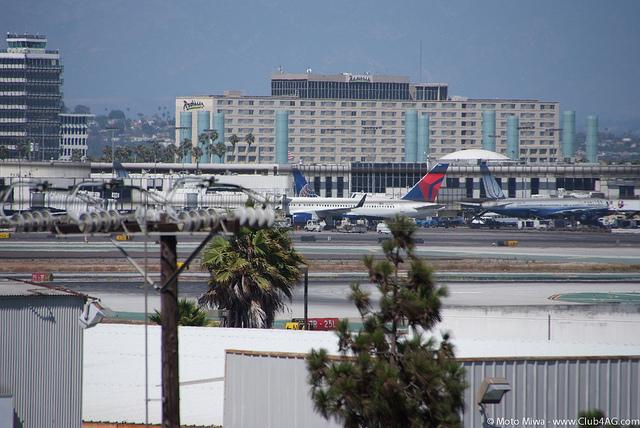Are those trees green?
Keep it brief. Yes. What hotel is in the background?
Short answer required. Hilton. Is this an airport?
Quick response, please. Yes. What kind of building is the black building on the left?
Be succinct. Office. 